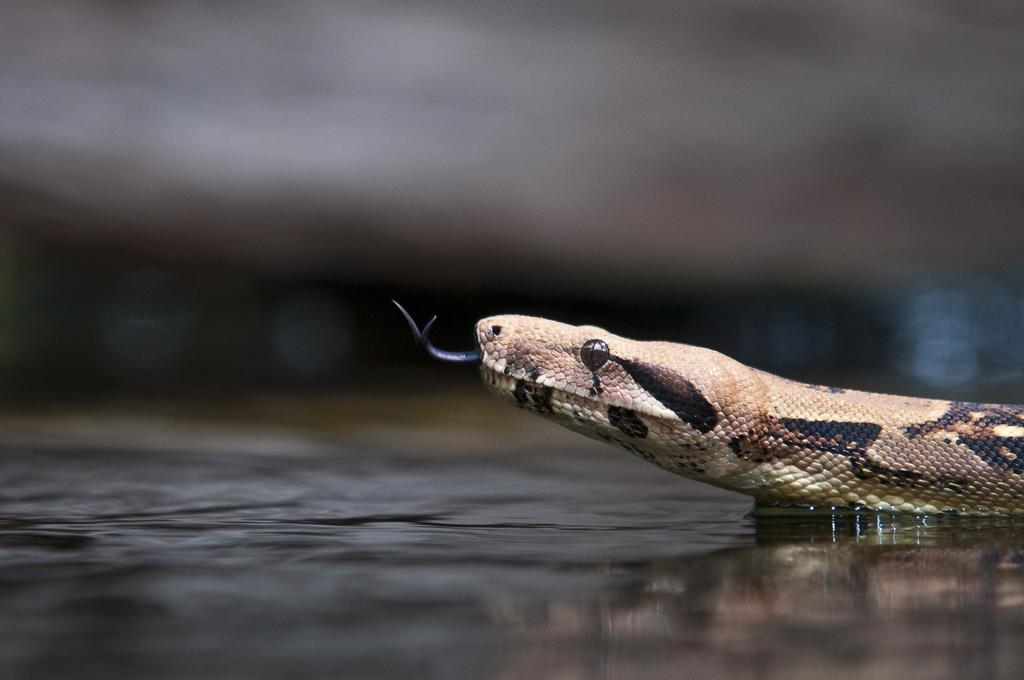What animal is present in the image? There is a snake in the image. Where is the snake located? The snake is on the ground. What part of the snake's body is visible? The snake's tongue and eye are visible. What type of afterthought is the snake holding in the image? There is no afterthought present in the image; it features a snake on the ground with its tongue and eye visible. 